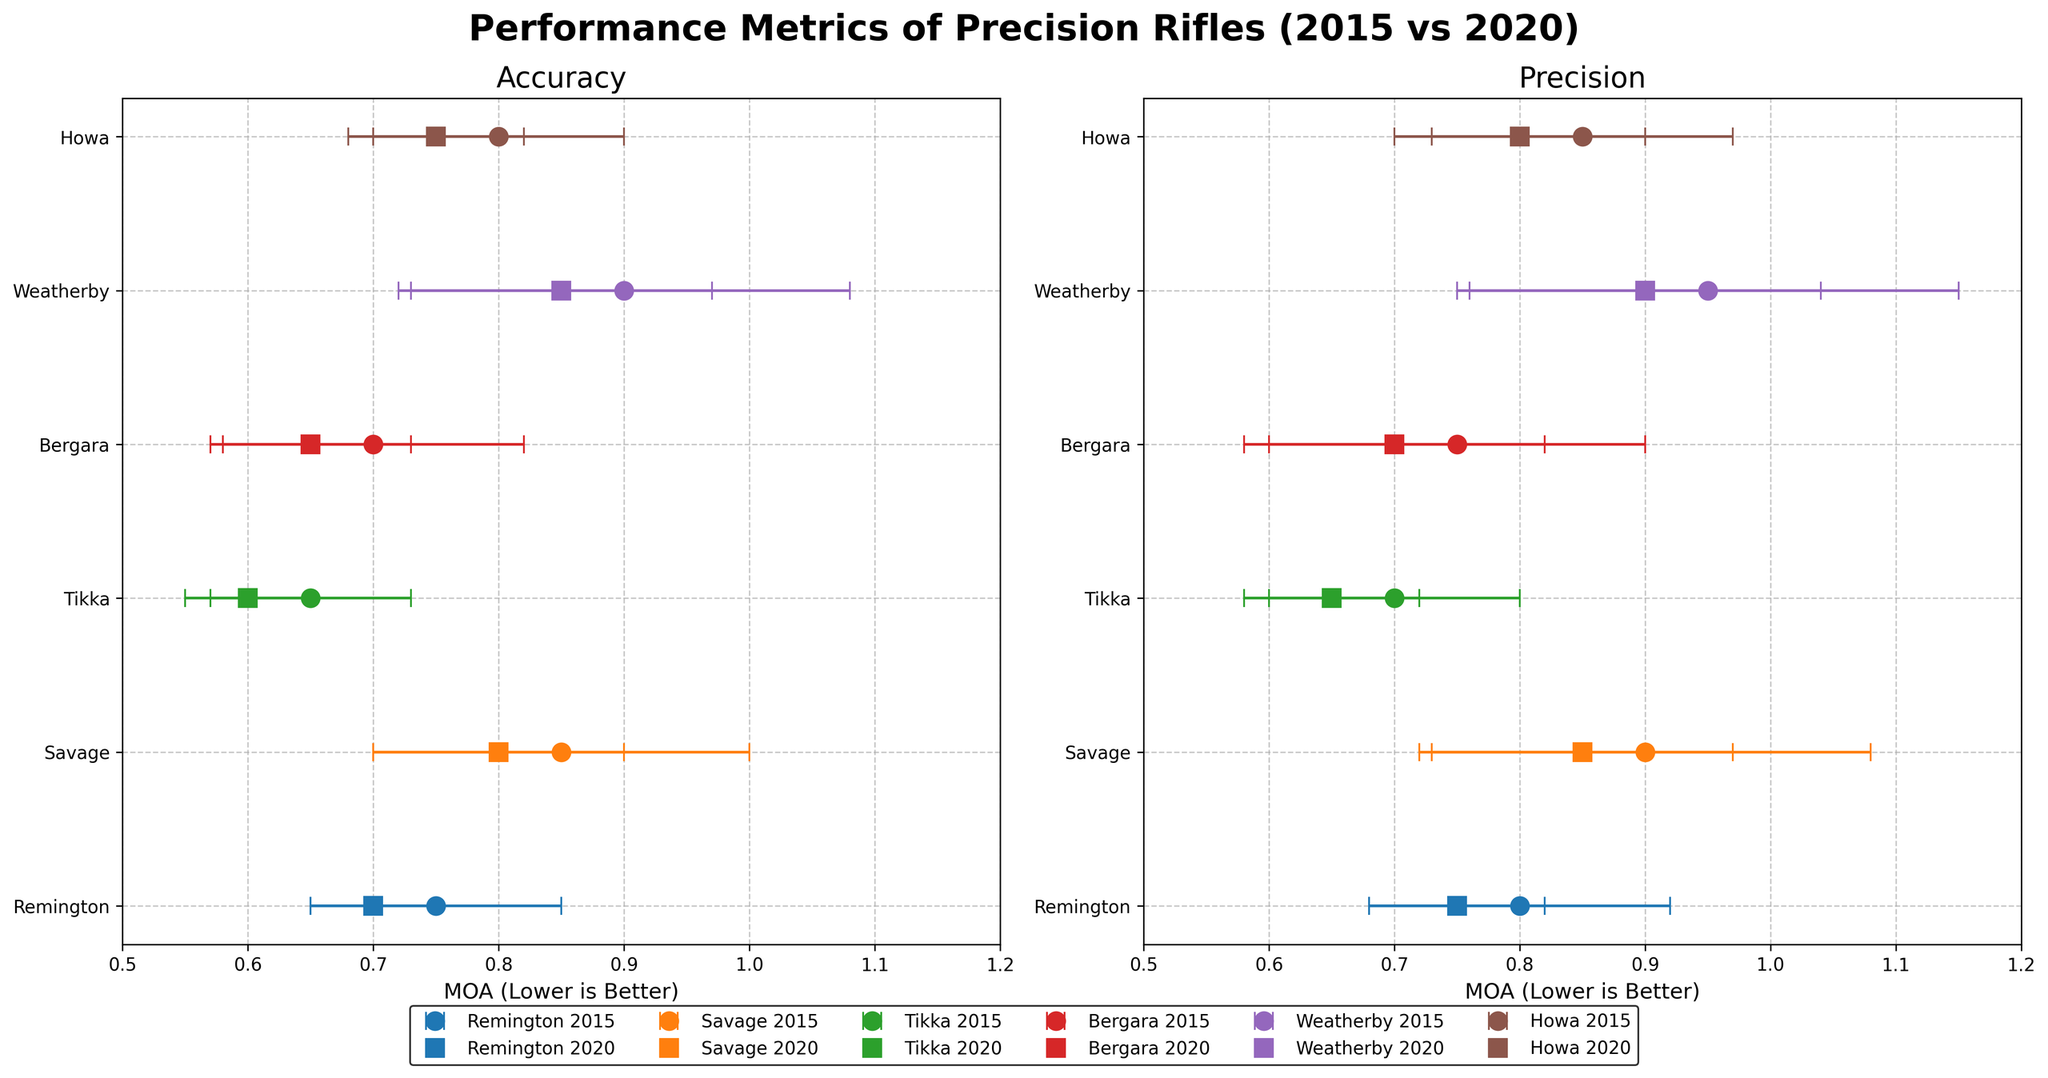How many rifle manufacturers are included in the plot? Look at the unique manufacturers listed on the y-axis of both subplots.
Answer: 6 What is the title of the figure? Read the bold title at the top center of the figure.
Answer: Performance Metrics of Precision Rifles (2015 vs 2020) Which manufacturer has the highest accuracy in 2020? Compare the accuracy MOA values for each manufacturer in 2020 in the Accuracy subplot, identified by square markers. Lower MOA indicates higher accuracy.
Answer: Tikka Which rifle model shows the greatest improvement in accuracy from 2015 to 2020? Subtract the 2020 accuracy MOA from the 2015 accuracy MOA for each rifle model. The largest positive difference shows the greatest improvement.
Answer: Weatherby Vanguard Which model has the lowest precision in 2015 and how does it compare to its precision in 2020? In the Precision subplot, find the model with the highest MOA in 2015 (circle markers). Compare this value to its 2020 MOA (square markers).
Answer: Weatherby Vanguard, which improved from 0.95 MOA to 0.90 MOA Which manufacturer shows the least variation (error bars) in accuracy in 2020? Find the smallest error bars (capsize) in the Accuracy subplot among the 2020 values (square markers).
Answer: Tikka Compare the precision of the Remington Model 700 between 2015 and 2020. Look at the Precision subplot for Remington 2015 (circle marker) and 2020 (square marker) MOA values and their error bars.
Answer: Slight improvement from 0.80 MOA to 0.75 MOA What is the color representing Savage on the plot? Look at the legend and identify the color associated with Savage.
Answer: Orange Which manufacturer has the most consistent performance in terms of accuracy and precision from 2015 to 2020? Examine both subplots for manufacturers with the least change in accuracy and precision MOA values and smallest error bars over time. Consider consistency in both metrics.
Answer: Howa What is the average accuracy of the Bergara B-14 HMR over 2015 and 2020? Add the accuracy values for Bergara B-14 HMR in 2015 (0.70) and 2020 (0.65), then divide by 2.
Answer: 0.675 